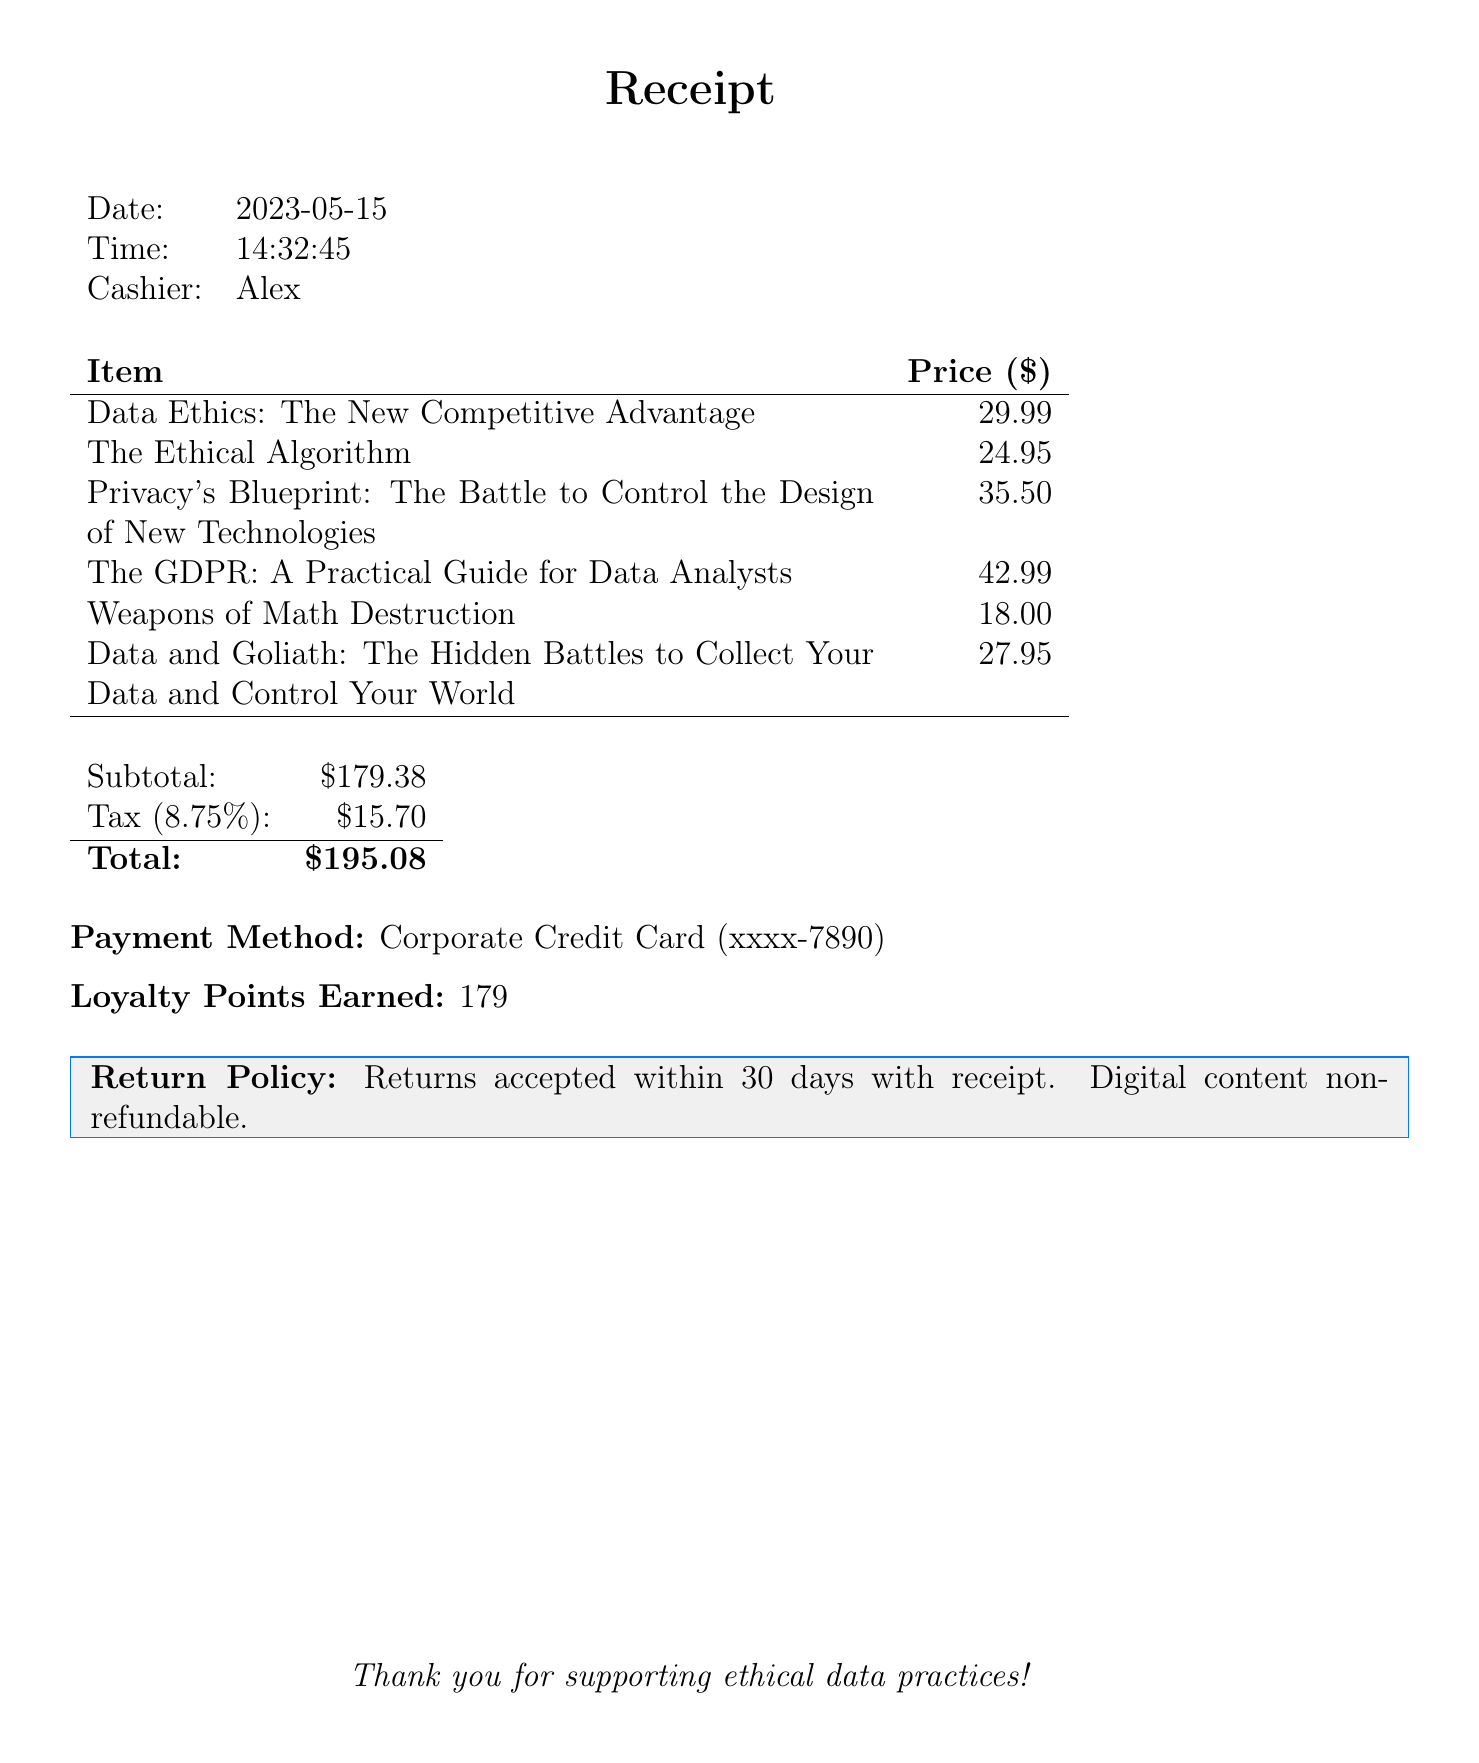What is the store name? The store name is provided at the top of the receipt.
Answer: TechBooks & Co Who is the cashier? The cashier's name is stated in the receipt.
Answer: Alex What is the date of the purchase? The date of the purchase is listed on the receipt.
Answer: 2023-05-15 What is the total amount spent? The total amount is the final sum noted at the bottom of the receipt.
Answer: $195.08 How many loyalty points were earned? The number of loyalty points earned is specified in the receipt.
Answer: 179 Which book has the highest price? To find the highest price, we compare all book prices listed on the receipt.
Answer: The GDPR: A Practical Guide for Data Analysts What is the subtotal before tax? The subtotal is the sum of all item prices before tax is added.
Answer: $179.38 What is the tax rate applied? The tax rate is explicitly mentioned in the receipt.
Answer: 8.75% What is the return policy? The return policy is stated in the receipt's footer.
Answer: Returns accepted within 30 days with receipt. Digital content non-refundable 